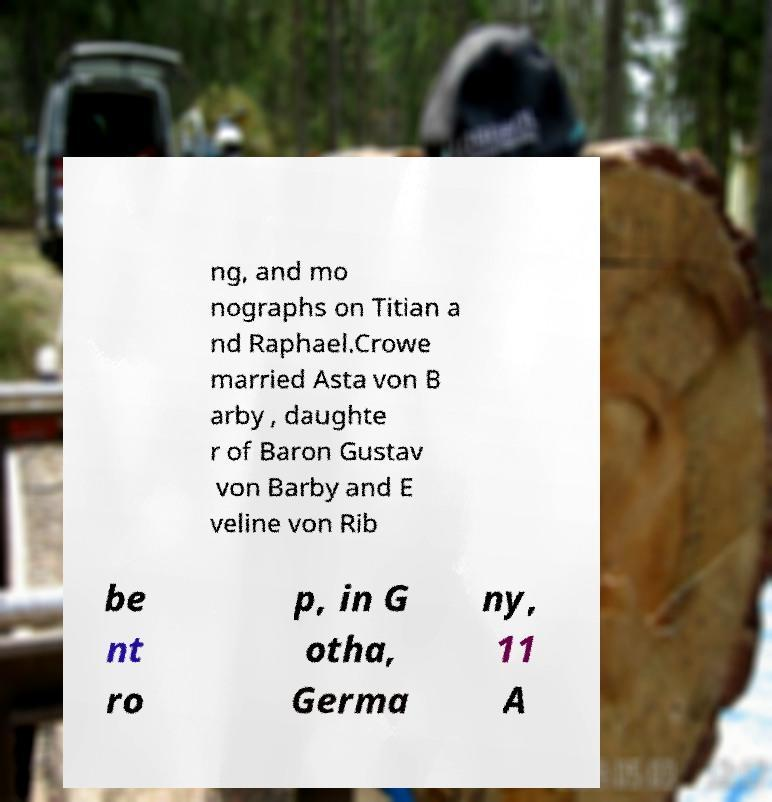What messages or text are displayed in this image? I need them in a readable, typed format. ng, and mo nographs on Titian a nd Raphael.Crowe married Asta von B arby , daughte r of Baron Gustav von Barby and E veline von Rib be nt ro p, in G otha, Germa ny, 11 A 